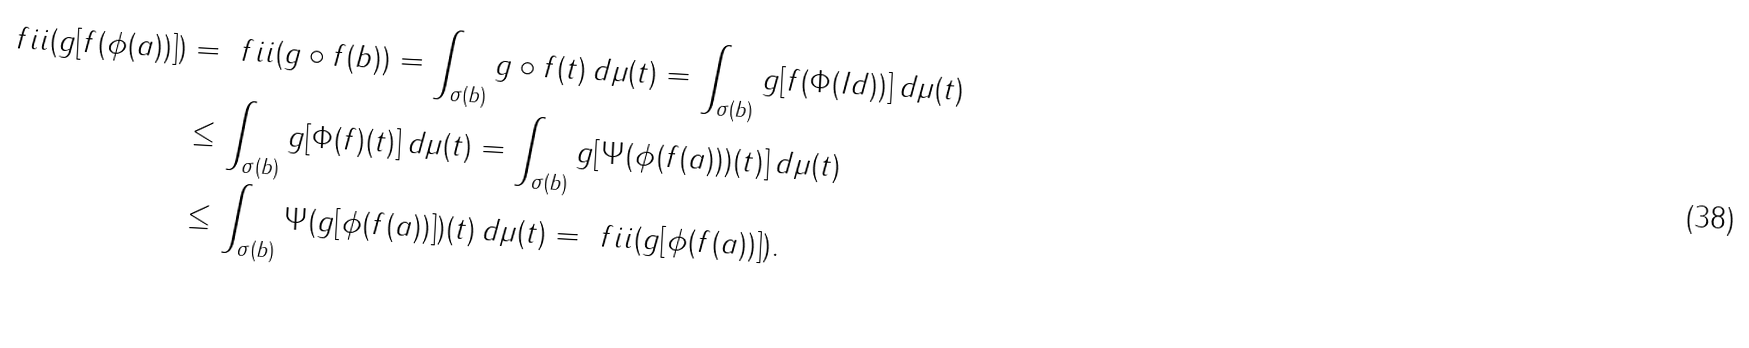<formula> <loc_0><loc_0><loc_500><loc_500>\ f i i ( g [ f ( \phi ( a ) ) ] ) & = \ f i i ( g \circ f ( b ) ) = \int _ { \sigma ( b ) } g \circ f ( t ) \, d \mu ( t ) = \int _ { \sigma ( b ) } g [ f ( \Phi ( I d ) ) ] \, d \mu ( t ) \\ & \leq \int _ { \sigma ( b ) } g [ \Phi ( f ) ( t ) ] \, d \mu ( t ) = \int _ { \sigma ( b ) } g [ \Psi ( \phi ( f ( a ) ) ) ( t ) ] \, d \mu ( t ) \\ & \leq \int _ { \sigma ( b ) } \Psi ( g [ \phi ( f ( a ) ) ] ) ( t ) \, d \mu ( t ) = \ f i i ( g [ \phi ( f ( a ) ) ] ) .</formula> 